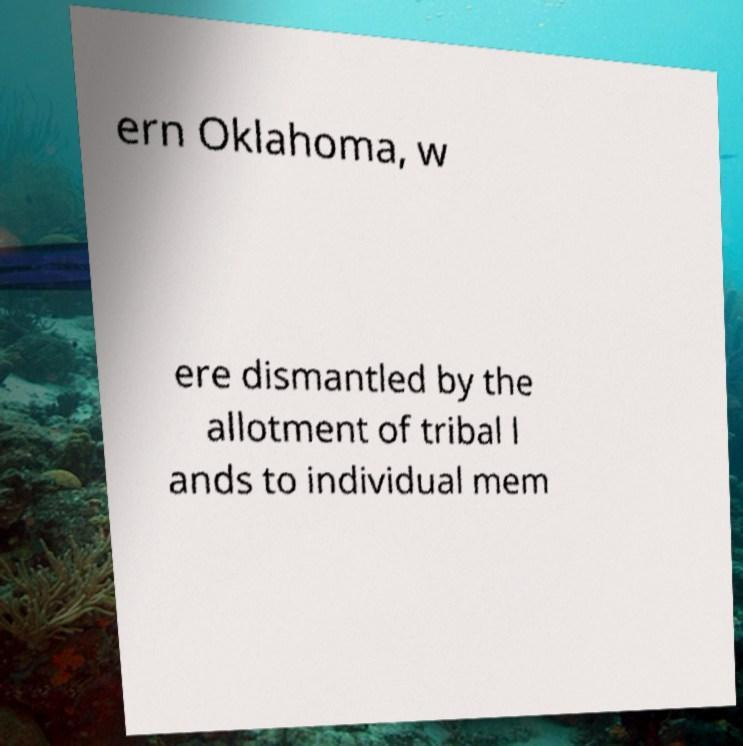There's text embedded in this image that I need extracted. Can you transcribe it verbatim? ern Oklahoma, w ere dismantled by the allotment of tribal l ands to individual mem 